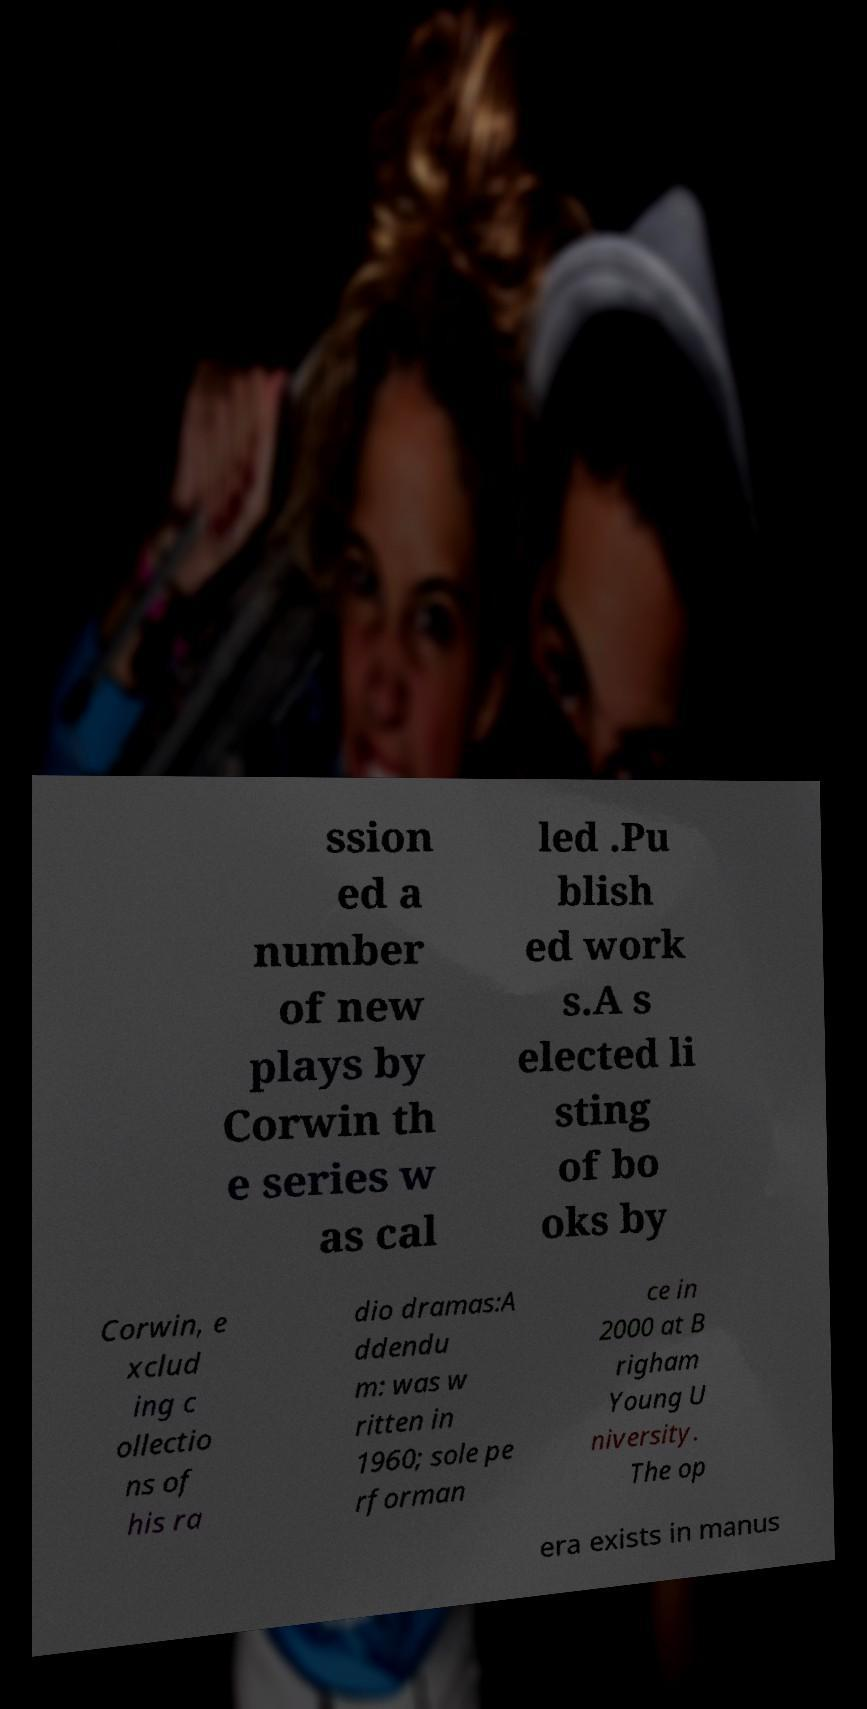Can you accurately transcribe the text from the provided image for me? ssion ed a number of new plays by Corwin th e series w as cal led .Pu blish ed work s.A s elected li sting of bo oks by Corwin, e xclud ing c ollectio ns of his ra dio dramas:A ddendu m: was w ritten in 1960; sole pe rforman ce in 2000 at B righam Young U niversity. The op era exists in manus 